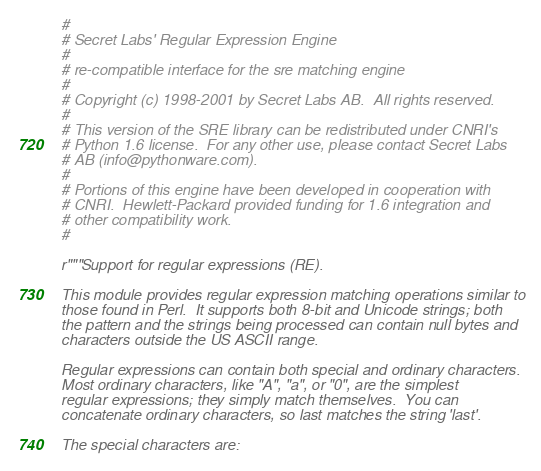<code> <loc_0><loc_0><loc_500><loc_500><_Python_>#
# Secret Labs' Regular Expression Engine
#
# re-compatible interface for the sre matching engine
#
# Copyright (c) 1998-2001 by Secret Labs AB.  All rights reserved.
#
# This version of the SRE library can be redistributed under CNRI's
# Python 1.6 license.  For any other use, please contact Secret Labs
# AB (info@pythonware.com).
#
# Portions of this engine have been developed in cooperation with
# CNRI.  Hewlett-Packard provided funding for 1.6 integration and
# other compatibility work.
#

r"""Support for regular expressions (RE).

This module provides regular expression matching operations similar to
those found in Perl.  It supports both 8-bit and Unicode strings; both
the pattern and the strings being processed can contain null bytes and
characters outside the US ASCII range.

Regular expressions can contain both special and ordinary characters.
Most ordinary characters, like "A", "a", or "0", are the simplest
regular expressions; they simply match themselves.  You can
concatenate ordinary characters, so last matches the string 'last'.

The special characters are:</code> 